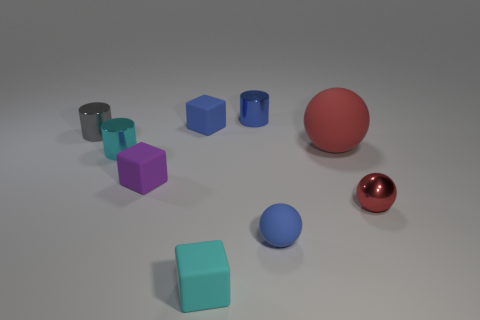Can you describe the color distribution among the objects in the image? Certainly! In the image, we see a spectrum of colors distributed among what looks like simplistic 3D models of geometric shapes. There is a blue rubber ball, three metallic objects in shades of red, gray, and copper, a purple cube, a cyan cube, and several other objects without clear color distinction from this perspective. 